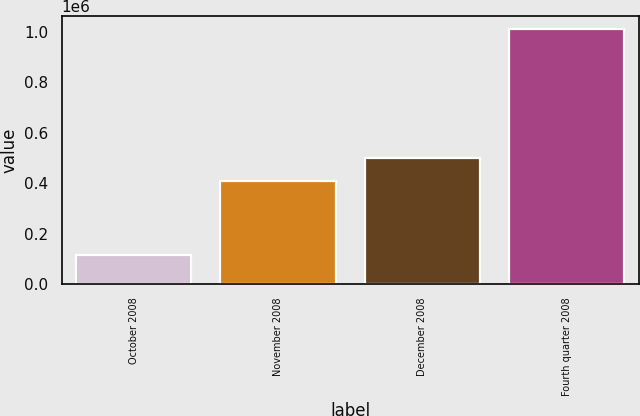Convert chart to OTSL. <chart><loc_0><loc_0><loc_500><loc_500><bar_chart><fcel>October 2008<fcel>November 2008<fcel>December 2008<fcel>Fourth quarter 2008<nl><fcel>117100<fcel>409100<fcel>498370<fcel>1.0098e+06<nl></chart> 